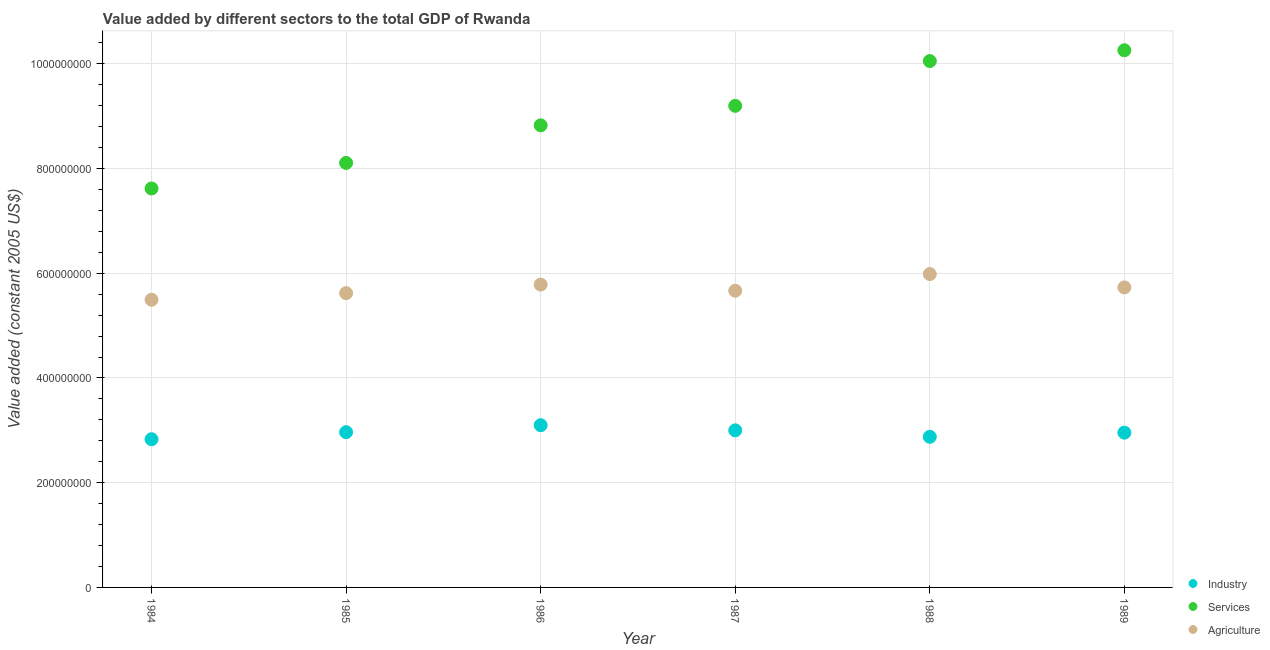How many different coloured dotlines are there?
Offer a terse response. 3. What is the value added by industrial sector in 1988?
Your response must be concise. 2.88e+08. Across all years, what is the maximum value added by services?
Give a very brief answer. 1.03e+09. Across all years, what is the minimum value added by industrial sector?
Give a very brief answer. 2.83e+08. What is the total value added by agricultural sector in the graph?
Offer a very short reply. 3.43e+09. What is the difference between the value added by services in 1985 and that in 1988?
Your answer should be compact. -1.95e+08. What is the difference between the value added by agricultural sector in 1989 and the value added by industrial sector in 1986?
Provide a succinct answer. 2.63e+08. What is the average value added by industrial sector per year?
Make the answer very short. 2.95e+08. In the year 1989, what is the difference between the value added by industrial sector and value added by agricultural sector?
Your answer should be compact. -2.77e+08. What is the ratio of the value added by services in 1985 to that in 1989?
Offer a terse response. 0.79. Is the difference between the value added by services in 1985 and 1986 greater than the difference between the value added by industrial sector in 1985 and 1986?
Offer a terse response. No. What is the difference between the highest and the second highest value added by services?
Your response must be concise. 2.06e+07. What is the difference between the highest and the lowest value added by services?
Provide a succinct answer. 2.64e+08. Does the value added by services monotonically increase over the years?
Give a very brief answer. Yes. Is the value added by agricultural sector strictly greater than the value added by services over the years?
Make the answer very short. No. How many years are there in the graph?
Your answer should be compact. 6. What is the difference between two consecutive major ticks on the Y-axis?
Ensure brevity in your answer.  2.00e+08. How many legend labels are there?
Your answer should be very brief. 3. How are the legend labels stacked?
Keep it short and to the point. Vertical. What is the title of the graph?
Your answer should be very brief. Value added by different sectors to the total GDP of Rwanda. Does "Domestic" appear as one of the legend labels in the graph?
Give a very brief answer. No. What is the label or title of the X-axis?
Provide a short and direct response. Year. What is the label or title of the Y-axis?
Your response must be concise. Value added (constant 2005 US$). What is the Value added (constant 2005 US$) of Industry in 1984?
Give a very brief answer. 2.83e+08. What is the Value added (constant 2005 US$) of Services in 1984?
Provide a short and direct response. 7.62e+08. What is the Value added (constant 2005 US$) in Agriculture in 1984?
Your answer should be very brief. 5.49e+08. What is the Value added (constant 2005 US$) of Industry in 1985?
Provide a succinct answer. 2.96e+08. What is the Value added (constant 2005 US$) in Services in 1985?
Offer a terse response. 8.11e+08. What is the Value added (constant 2005 US$) in Agriculture in 1985?
Keep it short and to the point. 5.62e+08. What is the Value added (constant 2005 US$) of Industry in 1986?
Make the answer very short. 3.10e+08. What is the Value added (constant 2005 US$) of Services in 1986?
Offer a very short reply. 8.82e+08. What is the Value added (constant 2005 US$) of Agriculture in 1986?
Your answer should be very brief. 5.78e+08. What is the Value added (constant 2005 US$) in Industry in 1987?
Your answer should be compact. 3.00e+08. What is the Value added (constant 2005 US$) of Services in 1987?
Make the answer very short. 9.20e+08. What is the Value added (constant 2005 US$) in Agriculture in 1987?
Keep it short and to the point. 5.67e+08. What is the Value added (constant 2005 US$) of Industry in 1988?
Your answer should be very brief. 2.88e+08. What is the Value added (constant 2005 US$) of Services in 1988?
Make the answer very short. 1.01e+09. What is the Value added (constant 2005 US$) of Agriculture in 1988?
Give a very brief answer. 5.98e+08. What is the Value added (constant 2005 US$) of Industry in 1989?
Make the answer very short. 2.96e+08. What is the Value added (constant 2005 US$) in Services in 1989?
Keep it short and to the point. 1.03e+09. What is the Value added (constant 2005 US$) in Agriculture in 1989?
Make the answer very short. 5.73e+08. Across all years, what is the maximum Value added (constant 2005 US$) in Industry?
Offer a very short reply. 3.10e+08. Across all years, what is the maximum Value added (constant 2005 US$) of Services?
Give a very brief answer. 1.03e+09. Across all years, what is the maximum Value added (constant 2005 US$) of Agriculture?
Give a very brief answer. 5.98e+08. Across all years, what is the minimum Value added (constant 2005 US$) of Industry?
Offer a very short reply. 2.83e+08. Across all years, what is the minimum Value added (constant 2005 US$) of Services?
Give a very brief answer. 7.62e+08. Across all years, what is the minimum Value added (constant 2005 US$) in Agriculture?
Provide a short and direct response. 5.49e+08. What is the total Value added (constant 2005 US$) of Industry in the graph?
Your answer should be very brief. 1.77e+09. What is the total Value added (constant 2005 US$) of Services in the graph?
Provide a succinct answer. 5.41e+09. What is the total Value added (constant 2005 US$) of Agriculture in the graph?
Ensure brevity in your answer.  3.43e+09. What is the difference between the Value added (constant 2005 US$) of Industry in 1984 and that in 1985?
Offer a terse response. -1.35e+07. What is the difference between the Value added (constant 2005 US$) of Services in 1984 and that in 1985?
Your answer should be compact. -4.87e+07. What is the difference between the Value added (constant 2005 US$) in Agriculture in 1984 and that in 1985?
Offer a very short reply. -1.26e+07. What is the difference between the Value added (constant 2005 US$) in Industry in 1984 and that in 1986?
Ensure brevity in your answer.  -2.68e+07. What is the difference between the Value added (constant 2005 US$) of Services in 1984 and that in 1986?
Your answer should be very brief. -1.21e+08. What is the difference between the Value added (constant 2005 US$) of Agriculture in 1984 and that in 1986?
Provide a succinct answer. -2.89e+07. What is the difference between the Value added (constant 2005 US$) of Industry in 1984 and that in 1987?
Offer a terse response. -1.70e+07. What is the difference between the Value added (constant 2005 US$) in Services in 1984 and that in 1987?
Offer a very short reply. -1.58e+08. What is the difference between the Value added (constant 2005 US$) of Agriculture in 1984 and that in 1987?
Give a very brief answer. -1.72e+07. What is the difference between the Value added (constant 2005 US$) of Industry in 1984 and that in 1988?
Your answer should be very brief. -4.63e+06. What is the difference between the Value added (constant 2005 US$) in Services in 1984 and that in 1988?
Ensure brevity in your answer.  -2.43e+08. What is the difference between the Value added (constant 2005 US$) in Agriculture in 1984 and that in 1988?
Your response must be concise. -4.91e+07. What is the difference between the Value added (constant 2005 US$) in Industry in 1984 and that in 1989?
Offer a very short reply. -1.26e+07. What is the difference between the Value added (constant 2005 US$) of Services in 1984 and that in 1989?
Give a very brief answer. -2.64e+08. What is the difference between the Value added (constant 2005 US$) in Agriculture in 1984 and that in 1989?
Keep it short and to the point. -2.36e+07. What is the difference between the Value added (constant 2005 US$) in Industry in 1985 and that in 1986?
Offer a very short reply. -1.33e+07. What is the difference between the Value added (constant 2005 US$) of Services in 1985 and that in 1986?
Your response must be concise. -7.18e+07. What is the difference between the Value added (constant 2005 US$) of Agriculture in 1985 and that in 1986?
Keep it short and to the point. -1.63e+07. What is the difference between the Value added (constant 2005 US$) in Industry in 1985 and that in 1987?
Your answer should be compact. -3.52e+06. What is the difference between the Value added (constant 2005 US$) of Services in 1985 and that in 1987?
Offer a terse response. -1.09e+08. What is the difference between the Value added (constant 2005 US$) of Agriculture in 1985 and that in 1987?
Provide a short and direct response. -4.62e+06. What is the difference between the Value added (constant 2005 US$) in Industry in 1985 and that in 1988?
Provide a succinct answer. 8.83e+06. What is the difference between the Value added (constant 2005 US$) in Services in 1985 and that in 1988?
Offer a very short reply. -1.95e+08. What is the difference between the Value added (constant 2005 US$) in Agriculture in 1985 and that in 1988?
Ensure brevity in your answer.  -3.65e+07. What is the difference between the Value added (constant 2005 US$) in Industry in 1985 and that in 1989?
Your answer should be compact. 8.79e+05. What is the difference between the Value added (constant 2005 US$) in Services in 1985 and that in 1989?
Your answer should be very brief. -2.15e+08. What is the difference between the Value added (constant 2005 US$) in Agriculture in 1985 and that in 1989?
Offer a very short reply. -1.10e+07. What is the difference between the Value added (constant 2005 US$) of Industry in 1986 and that in 1987?
Provide a short and direct response. 9.83e+06. What is the difference between the Value added (constant 2005 US$) of Services in 1986 and that in 1987?
Your answer should be very brief. -3.72e+07. What is the difference between the Value added (constant 2005 US$) in Agriculture in 1986 and that in 1987?
Provide a short and direct response. 1.17e+07. What is the difference between the Value added (constant 2005 US$) of Industry in 1986 and that in 1988?
Make the answer very short. 2.22e+07. What is the difference between the Value added (constant 2005 US$) in Services in 1986 and that in 1988?
Keep it short and to the point. -1.23e+08. What is the difference between the Value added (constant 2005 US$) in Agriculture in 1986 and that in 1988?
Make the answer very short. -2.02e+07. What is the difference between the Value added (constant 2005 US$) of Industry in 1986 and that in 1989?
Your answer should be compact. 1.42e+07. What is the difference between the Value added (constant 2005 US$) in Services in 1986 and that in 1989?
Keep it short and to the point. -1.43e+08. What is the difference between the Value added (constant 2005 US$) of Agriculture in 1986 and that in 1989?
Make the answer very short. 5.34e+06. What is the difference between the Value added (constant 2005 US$) of Industry in 1987 and that in 1988?
Make the answer very short. 1.23e+07. What is the difference between the Value added (constant 2005 US$) of Services in 1987 and that in 1988?
Your answer should be compact. -8.55e+07. What is the difference between the Value added (constant 2005 US$) of Agriculture in 1987 and that in 1988?
Your response must be concise. -3.19e+07. What is the difference between the Value added (constant 2005 US$) in Industry in 1987 and that in 1989?
Provide a succinct answer. 4.40e+06. What is the difference between the Value added (constant 2005 US$) of Services in 1987 and that in 1989?
Provide a short and direct response. -1.06e+08. What is the difference between the Value added (constant 2005 US$) in Agriculture in 1987 and that in 1989?
Offer a terse response. -6.34e+06. What is the difference between the Value added (constant 2005 US$) in Industry in 1988 and that in 1989?
Your answer should be compact. -7.95e+06. What is the difference between the Value added (constant 2005 US$) in Services in 1988 and that in 1989?
Offer a terse response. -2.06e+07. What is the difference between the Value added (constant 2005 US$) of Agriculture in 1988 and that in 1989?
Ensure brevity in your answer.  2.55e+07. What is the difference between the Value added (constant 2005 US$) in Industry in 1984 and the Value added (constant 2005 US$) in Services in 1985?
Offer a terse response. -5.28e+08. What is the difference between the Value added (constant 2005 US$) of Industry in 1984 and the Value added (constant 2005 US$) of Agriculture in 1985?
Your response must be concise. -2.79e+08. What is the difference between the Value added (constant 2005 US$) of Services in 1984 and the Value added (constant 2005 US$) of Agriculture in 1985?
Ensure brevity in your answer.  2.00e+08. What is the difference between the Value added (constant 2005 US$) in Industry in 1984 and the Value added (constant 2005 US$) in Services in 1986?
Offer a very short reply. -5.99e+08. What is the difference between the Value added (constant 2005 US$) in Industry in 1984 and the Value added (constant 2005 US$) in Agriculture in 1986?
Give a very brief answer. -2.95e+08. What is the difference between the Value added (constant 2005 US$) of Services in 1984 and the Value added (constant 2005 US$) of Agriculture in 1986?
Your answer should be compact. 1.84e+08. What is the difference between the Value added (constant 2005 US$) of Industry in 1984 and the Value added (constant 2005 US$) of Services in 1987?
Your response must be concise. -6.37e+08. What is the difference between the Value added (constant 2005 US$) of Industry in 1984 and the Value added (constant 2005 US$) of Agriculture in 1987?
Provide a succinct answer. -2.84e+08. What is the difference between the Value added (constant 2005 US$) of Services in 1984 and the Value added (constant 2005 US$) of Agriculture in 1987?
Keep it short and to the point. 1.95e+08. What is the difference between the Value added (constant 2005 US$) of Industry in 1984 and the Value added (constant 2005 US$) of Services in 1988?
Ensure brevity in your answer.  -7.22e+08. What is the difference between the Value added (constant 2005 US$) in Industry in 1984 and the Value added (constant 2005 US$) in Agriculture in 1988?
Ensure brevity in your answer.  -3.15e+08. What is the difference between the Value added (constant 2005 US$) of Services in 1984 and the Value added (constant 2005 US$) of Agriculture in 1988?
Offer a very short reply. 1.63e+08. What is the difference between the Value added (constant 2005 US$) in Industry in 1984 and the Value added (constant 2005 US$) in Services in 1989?
Offer a terse response. -7.43e+08. What is the difference between the Value added (constant 2005 US$) of Industry in 1984 and the Value added (constant 2005 US$) of Agriculture in 1989?
Offer a terse response. -2.90e+08. What is the difference between the Value added (constant 2005 US$) in Services in 1984 and the Value added (constant 2005 US$) in Agriculture in 1989?
Make the answer very short. 1.89e+08. What is the difference between the Value added (constant 2005 US$) of Industry in 1985 and the Value added (constant 2005 US$) of Services in 1986?
Your response must be concise. -5.86e+08. What is the difference between the Value added (constant 2005 US$) of Industry in 1985 and the Value added (constant 2005 US$) of Agriculture in 1986?
Ensure brevity in your answer.  -2.82e+08. What is the difference between the Value added (constant 2005 US$) in Services in 1985 and the Value added (constant 2005 US$) in Agriculture in 1986?
Make the answer very short. 2.32e+08. What is the difference between the Value added (constant 2005 US$) of Industry in 1985 and the Value added (constant 2005 US$) of Services in 1987?
Ensure brevity in your answer.  -6.23e+08. What is the difference between the Value added (constant 2005 US$) of Industry in 1985 and the Value added (constant 2005 US$) of Agriculture in 1987?
Ensure brevity in your answer.  -2.70e+08. What is the difference between the Value added (constant 2005 US$) in Services in 1985 and the Value added (constant 2005 US$) in Agriculture in 1987?
Offer a very short reply. 2.44e+08. What is the difference between the Value added (constant 2005 US$) in Industry in 1985 and the Value added (constant 2005 US$) in Services in 1988?
Give a very brief answer. -7.09e+08. What is the difference between the Value added (constant 2005 US$) in Industry in 1985 and the Value added (constant 2005 US$) in Agriculture in 1988?
Provide a succinct answer. -3.02e+08. What is the difference between the Value added (constant 2005 US$) in Services in 1985 and the Value added (constant 2005 US$) in Agriculture in 1988?
Provide a short and direct response. 2.12e+08. What is the difference between the Value added (constant 2005 US$) of Industry in 1985 and the Value added (constant 2005 US$) of Services in 1989?
Offer a very short reply. -7.29e+08. What is the difference between the Value added (constant 2005 US$) in Industry in 1985 and the Value added (constant 2005 US$) in Agriculture in 1989?
Offer a very short reply. -2.76e+08. What is the difference between the Value added (constant 2005 US$) in Services in 1985 and the Value added (constant 2005 US$) in Agriculture in 1989?
Offer a terse response. 2.38e+08. What is the difference between the Value added (constant 2005 US$) of Industry in 1986 and the Value added (constant 2005 US$) of Services in 1987?
Your answer should be compact. -6.10e+08. What is the difference between the Value added (constant 2005 US$) in Industry in 1986 and the Value added (constant 2005 US$) in Agriculture in 1987?
Offer a terse response. -2.57e+08. What is the difference between the Value added (constant 2005 US$) in Services in 1986 and the Value added (constant 2005 US$) in Agriculture in 1987?
Offer a terse response. 3.16e+08. What is the difference between the Value added (constant 2005 US$) in Industry in 1986 and the Value added (constant 2005 US$) in Services in 1988?
Provide a succinct answer. -6.95e+08. What is the difference between the Value added (constant 2005 US$) of Industry in 1986 and the Value added (constant 2005 US$) of Agriculture in 1988?
Provide a short and direct response. -2.89e+08. What is the difference between the Value added (constant 2005 US$) of Services in 1986 and the Value added (constant 2005 US$) of Agriculture in 1988?
Make the answer very short. 2.84e+08. What is the difference between the Value added (constant 2005 US$) of Industry in 1986 and the Value added (constant 2005 US$) of Services in 1989?
Ensure brevity in your answer.  -7.16e+08. What is the difference between the Value added (constant 2005 US$) of Industry in 1986 and the Value added (constant 2005 US$) of Agriculture in 1989?
Give a very brief answer. -2.63e+08. What is the difference between the Value added (constant 2005 US$) of Services in 1986 and the Value added (constant 2005 US$) of Agriculture in 1989?
Make the answer very short. 3.10e+08. What is the difference between the Value added (constant 2005 US$) in Industry in 1987 and the Value added (constant 2005 US$) in Services in 1988?
Give a very brief answer. -7.05e+08. What is the difference between the Value added (constant 2005 US$) in Industry in 1987 and the Value added (constant 2005 US$) in Agriculture in 1988?
Make the answer very short. -2.98e+08. What is the difference between the Value added (constant 2005 US$) in Services in 1987 and the Value added (constant 2005 US$) in Agriculture in 1988?
Provide a succinct answer. 3.21e+08. What is the difference between the Value added (constant 2005 US$) of Industry in 1987 and the Value added (constant 2005 US$) of Services in 1989?
Offer a terse response. -7.26e+08. What is the difference between the Value added (constant 2005 US$) in Industry in 1987 and the Value added (constant 2005 US$) in Agriculture in 1989?
Offer a very short reply. -2.73e+08. What is the difference between the Value added (constant 2005 US$) of Services in 1987 and the Value added (constant 2005 US$) of Agriculture in 1989?
Your answer should be compact. 3.47e+08. What is the difference between the Value added (constant 2005 US$) of Industry in 1988 and the Value added (constant 2005 US$) of Services in 1989?
Offer a very short reply. -7.38e+08. What is the difference between the Value added (constant 2005 US$) in Industry in 1988 and the Value added (constant 2005 US$) in Agriculture in 1989?
Your answer should be very brief. -2.85e+08. What is the difference between the Value added (constant 2005 US$) of Services in 1988 and the Value added (constant 2005 US$) of Agriculture in 1989?
Provide a short and direct response. 4.32e+08. What is the average Value added (constant 2005 US$) in Industry per year?
Your answer should be compact. 2.95e+08. What is the average Value added (constant 2005 US$) in Services per year?
Keep it short and to the point. 9.01e+08. What is the average Value added (constant 2005 US$) in Agriculture per year?
Your response must be concise. 5.71e+08. In the year 1984, what is the difference between the Value added (constant 2005 US$) in Industry and Value added (constant 2005 US$) in Services?
Give a very brief answer. -4.79e+08. In the year 1984, what is the difference between the Value added (constant 2005 US$) of Industry and Value added (constant 2005 US$) of Agriculture?
Ensure brevity in your answer.  -2.66e+08. In the year 1984, what is the difference between the Value added (constant 2005 US$) of Services and Value added (constant 2005 US$) of Agriculture?
Make the answer very short. 2.13e+08. In the year 1985, what is the difference between the Value added (constant 2005 US$) in Industry and Value added (constant 2005 US$) in Services?
Offer a very short reply. -5.14e+08. In the year 1985, what is the difference between the Value added (constant 2005 US$) in Industry and Value added (constant 2005 US$) in Agriculture?
Your response must be concise. -2.66e+08. In the year 1985, what is the difference between the Value added (constant 2005 US$) of Services and Value added (constant 2005 US$) of Agriculture?
Keep it short and to the point. 2.49e+08. In the year 1986, what is the difference between the Value added (constant 2005 US$) in Industry and Value added (constant 2005 US$) in Services?
Offer a very short reply. -5.73e+08. In the year 1986, what is the difference between the Value added (constant 2005 US$) in Industry and Value added (constant 2005 US$) in Agriculture?
Your response must be concise. -2.68e+08. In the year 1986, what is the difference between the Value added (constant 2005 US$) of Services and Value added (constant 2005 US$) of Agriculture?
Keep it short and to the point. 3.04e+08. In the year 1987, what is the difference between the Value added (constant 2005 US$) in Industry and Value added (constant 2005 US$) in Services?
Keep it short and to the point. -6.20e+08. In the year 1987, what is the difference between the Value added (constant 2005 US$) in Industry and Value added (constant 2005 US$) in Agriculture?
Offer a very short reply. -2.67e+08. In the year 1987, what is the difference between the Value added (constant 2005 US$) of Services and Value added (constant 2005 US$) of Agriculture?
Ensure brevity in your answer.  3.53e+08. In the year 1988, what is the difference between the Value added (constant 2005 US$) of Industry and Value added (constant 2005 US$) of Services?
Your answer should be very brief. -7.18e+08. In the year 1988, what is the difference between the Value added (constant 2005 US$) of Industry and Value added (constant 2005 US$) of Agriculture?
Provide a succinct answer. -3.11e+08. In the year 1988, what is the difference between the Value added (constant 2005 US$) of Services and Value added (constant 2005 US$) of Agriculture?
Offer a terse response. 4.07e+08. In the year 1989, what is the difference between the Value added (constant 2005 US$) of Industry and Value added (constant 2005 US$) of Services?
Ensure brevity in your answer.  -7.30e+08. In the year 1989, what is the difference between the Value added (constant 2005 US$) in Industry and Value added (constant 2005 US$) in Agriculture?
Ensure brevity in your answer.  -2.77e+08. In the year 1989, what is the difference between the Value added (constant 2005 US$) of Services and Value added (constant 2005 US$) of Agriculture?
Your response must be concise. 4.53e+08. What is the ratio of the Value added (constant 2005 US$) in Industry in 1984 to that in 1985?
Provide a succinct answer. 0.95. What is the ratio of the Value added (constant 2005 US$) of Services in 1984 to that in 1985?
Offer a very short reply. 0.94. What is the ratio of the Value added (constant 2005 US$) of Agriculture in 1984 to that in 1985?
Keep it short and to the point. 0.98. What is the ratio of the Value added (constant 2005 US$) of Industry in 1984 to that in 1986?
Offer a very short reply. 0.91. What is the ratio of the Value added (constant 2005 US$) in Services in 1984 to that in 1986?
Provide a short and direct response. 0.86. What is the ratio of the Value added (constant 2005 US$) in Agriculture in 1984 to that in 1986?
Your answer should be compact. 0.95. What is the ratio of the Value added (constant 2005 US$) of Industry in 1984 to that in 1987?
Offer a terse response. 0.94. What is the ratio of the Value added (constant 2005 US$) in Services in 1984 to that in 1987?
Keep it short and to the point. 0.83. What is the ratio of the Value added (constant 2005 US$) in Agriculture in 1984 to that in 1987?
Your answer should be very brief. 0.97. What is the ratio of the Value added (constant 2005 US$) in Industry in 1984 to that in 1988?
Provide a short and direct response. 0.98. What is the ratio of the Value added (constant 2005 US$) of Services in 1984 to that in 1988?
Ensure brevity in your answer.  0.76. What is the ratio of the Value added (constant 2005 US$) in Agriculture in 1984 to that in 1988?
Provide a short and direct response. 0.92. What is the ratio of the Value added (constant 2005 US$) in Industry in 1984 to that in 1989?
Your response must be concise. 0.96. What is the ratio of the Value added (constant 2005 US$) of Services in 1984 to that in 1989?
Your answer should be very brief. 0.74. What is the ratio of the Value added (constant 2005 US$) in Agriculture in 1984 to that in 1989?
Offer a very short reply. 0.96. What is the ratio of the Value added (constant 2005 US$) of Industry in 1985 to that in 1986?
Your response must be concise. 0.96. What is the ratio of the Value added (constant 2005 US$) in Services in 1985 to that in 1986?
Make the answer very short. 0.92. What is the ratio of the Value added (constant 2005 US$) of Agriculture in 1985 to that in 1986?
Make the answer very short. 0.97. What is the ratio of the Value added (constant 2005 US$) of Industry in 1985 to that in 1987?
Offer a very short reply. 0.99. What is the ratio of the Value added (constant 2005 US$) in Services in 1985 to that in 1987?
Your answer should be very brief. 0.88. What is the ratio of the Value added (constant 2005 US$) in Agriculture in 1985 to that in 1987?
Offer a terse response. 0.99. What is the ratio of the Value added (constant 2005 US$) in Industry in 1985 to that in 1988?
Your answer should be compact. 1.03. What is the ratio of the Value added (constant 2005 US$) in Services in 1985 to that in 1988?
Keep it short and to the point. 0.81. What is the ratio of the Value added (constant 2005 US$) of Agriculture in 1985 to that in 1988?
Your answer should be very brief. 0.94. What is the ratio of the Value added (constant 2005 US$) in Services in 1985 to that in 1989?
Your response must be concise. 0.79. What is the ratio of the Value added (constant 2005 US$) of Agriculture in 1985 to that in 1989?
Your response must be concise. 0.98. What is the ratio of the Value added (constant 2005 US$) in Industry in 1986 to that in 1987?
Provide a succinct answer. 1.03. What is the ratio of the Value added (constant 2005 US$) in Services in 1986 to that in 1987?
Ensure brevity in your answer.  0.96. What is the ratio of the Value added (constant 2005 US$) of Agriculture in 1986 to that in 1987?
Ensure brevity in your answer.  1.02. What is the ratio of the Value added (constant 2005 US$) in Industry in 1986 to that in 1988?
Ensure brevity in your answer.  1.08. What is the ratio of the Value added (constant 2005 US$) in Services in 1986 to that in 1988?
Keep it short and to the point. 0.88. What is the ratio of the Value added (constant 2005 US$) of Agriculture in 1986 to that in 1988?
Keep it short and to the point. 0.97. What is the ratio of the Value added (constant 2005 US$) in Industry in 1986 to that in 1989?
Your answer should be very brief. 1.05. What is the ratio of the Value added (constant 2005 US$) in Services in 1986 to that in 1989?
Your answer should be compact. 0.86. What is the ratio of the Value added (constant 2005 US$) in Agriculture in 1986 to that in 1989?
Your answer should be very brief. 1.01. What is the ratio of the Value added (constant 2005 US$) in Industry in 1987 to that in 1988?
Provide a succinct answer. 1.04. What is the ratio of the Value added (constant 2005 US$) in Services in 1987 to that in 1988?
Provide a short and direct response. 0.91. What is the ratio of the Value added (constant 2005 US$) in Agriculture in 1987 to that in 1988?
Provide a short and direct response. 0.95. What is the ratio of the Value added (constant 2005 US$) in Industry in 1987 to that in 1989?
Give a very brief answer. 1.01. What is the ratio of the Value added (constant 2005 US$) of Services in 1987 to that in 1989?
Provide a short and direct response. 0.9. What is the ratio of the Value added (constant 2005 US$) of Agriculture in 1987 to that in 1989?
Provide a short and direct response. 0.99. What is the ratio of the Value added (constant 2005 US$) in Industry in 1988 to that in 1989?
Keep it short and to the point. 0.97. What is the ratio of the Value added (constant 2005 US$) of Services in 1988 to that in 1989?
Your response must be concise. 0.98. What is the ratio of the Value added (constant 2005 US$) of Agriculture in 1988 to that in 1989?
Ensure brevity in your answer.  1.04. What is the difference between the highest and the second highest Value added (constant 2005 US$) in Industry?
Make the answer very short. 9.83e+06. What is the difference between the highest and the second highest Value added (constant 2005 US$) in Services?
Your answer should be very brief. 2.06e+07. What is the difference between the highest and the second highest Value added (constant 2005 US$) in Agriculture?
Keep it short and to the point. 2.02e+07. What is the difference between the highest and the lowest Value added (constant 2005 US$) in Industry?
Keep it short and to the point. 2.68e+07. What is the difference between the highest and the lowest Value added (constant 2005 US$) in Services?
Provide a short and direct response. 2.64e+08. What is the difference between the highest and the lowest Value added (constant 2005 US$) in Agriculture?
Provide a succinct answer. 4.91e+07. 